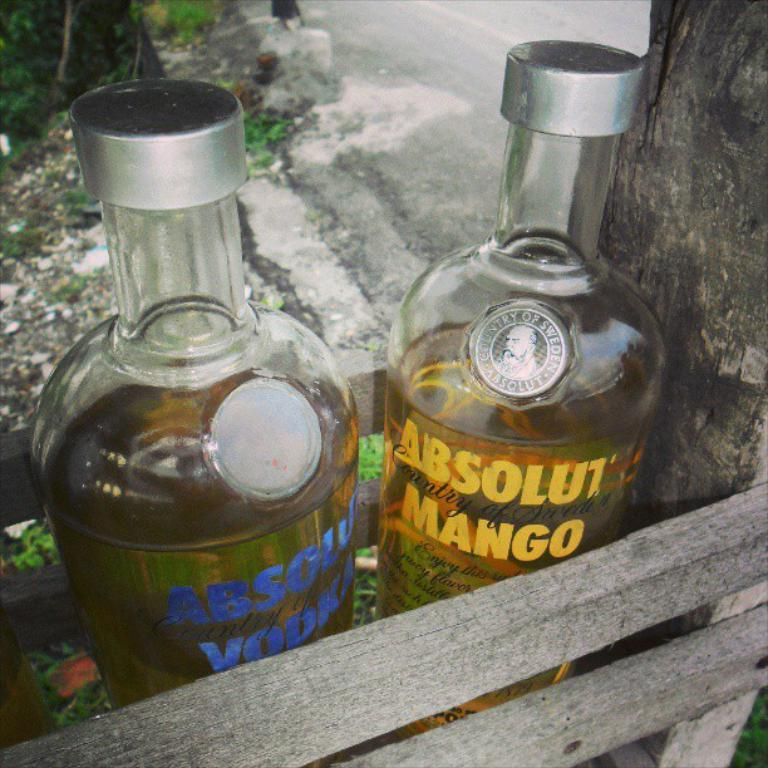<image>
Summarize the visual content of the image. Two bottles of absolute mango and absolute vodka sitting in a wooden box. 